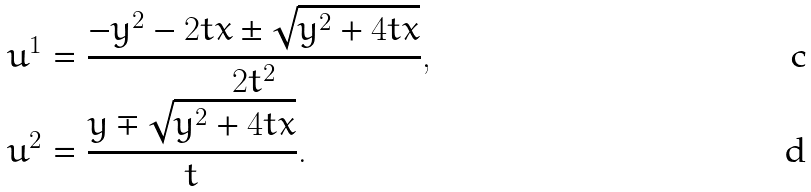Convert formula to latex. <formula><loc_0><loc_0><loc_500><loc_500>& u ^ { 1 } = \frac { - y ^ { 2 } - 2 t x \pm \sqrt { y ^ { 2 } + 4 t x } } { 2 t ^ { 2 } } , \\ & u ^ { 2 } = \frac { y \mp \sqrt { { y } ^ { 2 } + 4 t x } } { t } .</formula> 